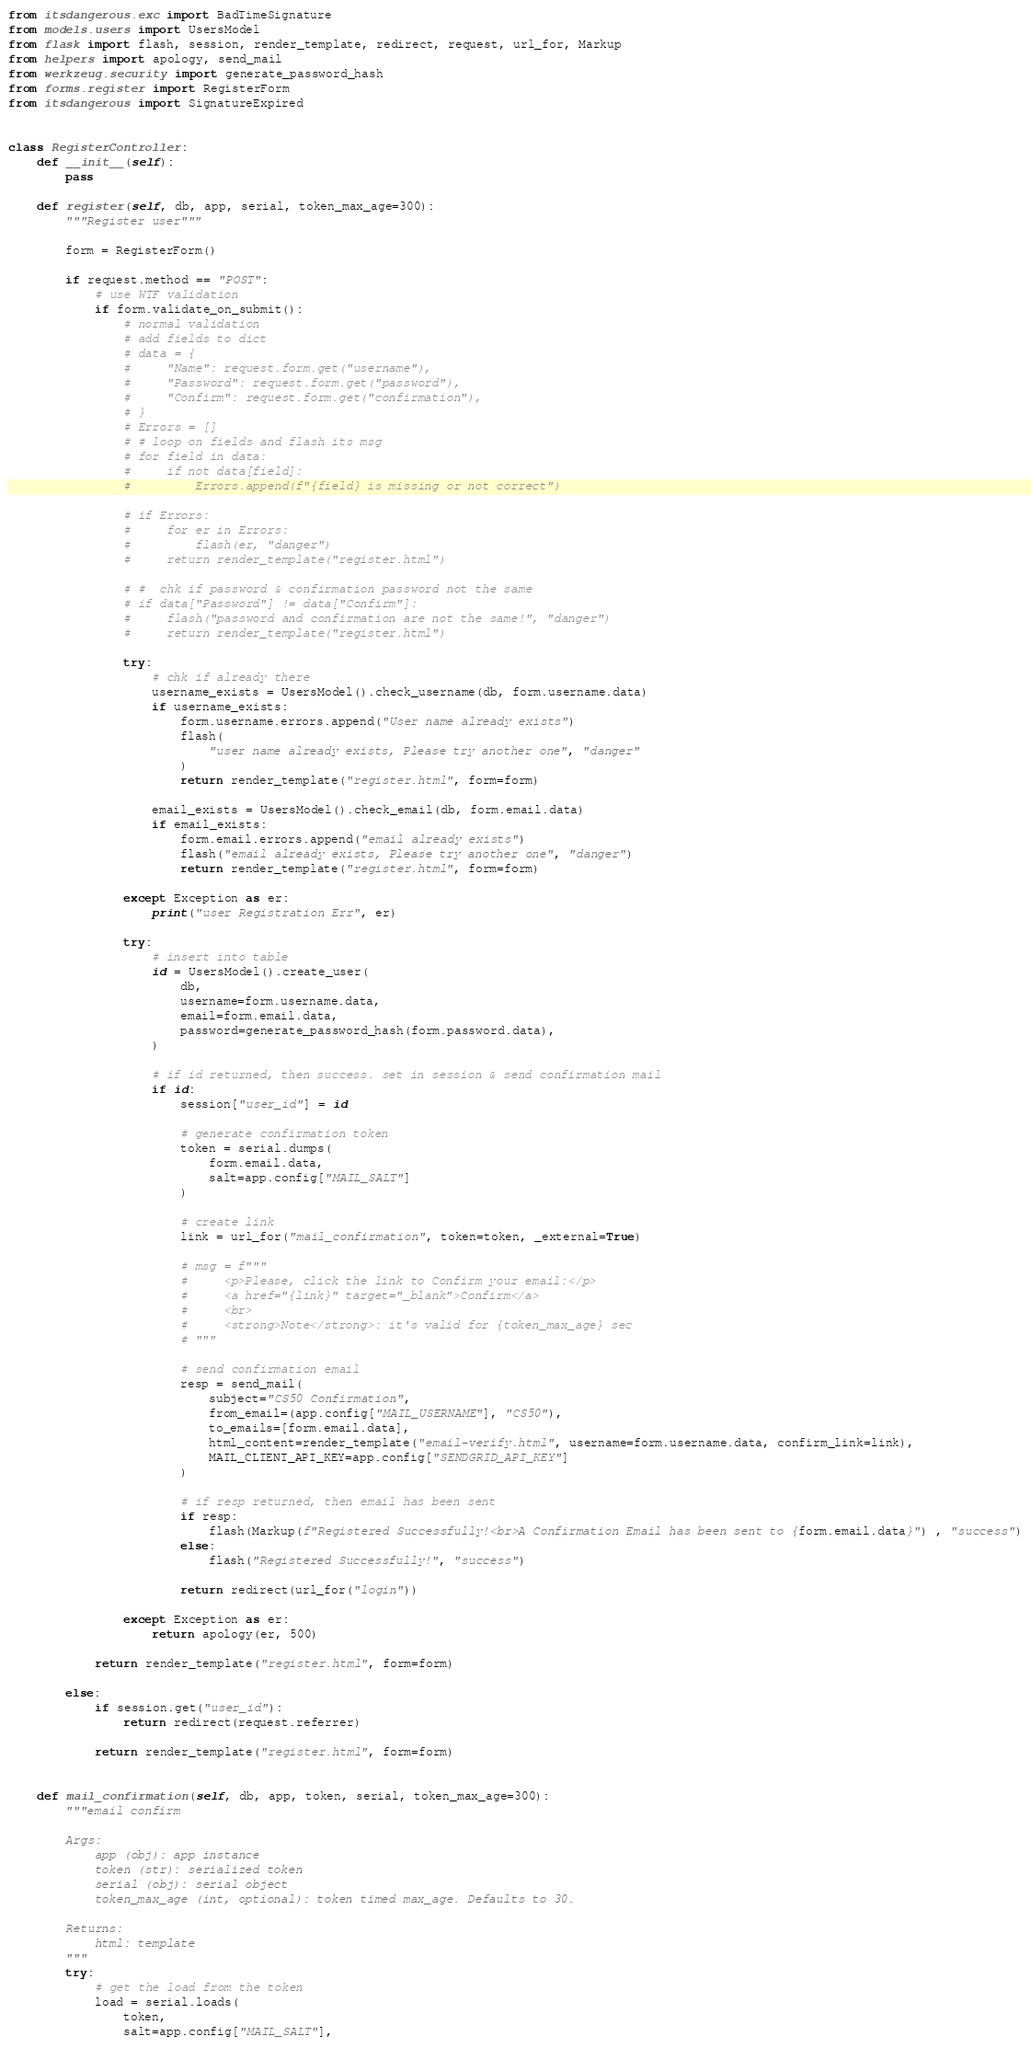<code> <loc_0><loc_0><loc_500><loc_500><_Python_>from itsdangerous.exc import BadTimeSignature
from models.users import UsersModel
from flask import flash, session, render_template, redirect, request, url_for, Markup
from helpers import apology, send_mail
from werkzeug.security import generate_password_hash
from forms.register import RegisterForm
from itsdangerous import SignatureExpired


class RegisterController:
    def __init__(self):
        pass

    def register(self, db, app, serial, token_max_age=300):
        """Register user"""

        form = RegisterForm()

        if request.method == "POST":
            # use WTF validation
            if form.validate_on_submit():
                # normal validation
                # add fields to dict
                # data = {
                #     "Name": request.form.get("username"),
                #     "Password": request.form.get("password"),
                #     "Confirm": request.form.get("confirmation"),
                # }
                # Errors = []
                # # loop on fields and flash its msg
                # for field in data:
                #     if not data[field]:
                #         Errors.append(f"{field} is missing or not correct")

                # if Errors:
                #     for er in Errors:
                #         flash(er, "danger")
                #     return render_template("register.html")

                # #  chk if password & confirmation password not the same
                # if data["Password"] != data["Confirm"]:
                #     flash("password and confirmation are not the same!", "danger")
                #     return render_template("register.html")

                try:
                    # chk if already there
                    username_exists = UsersModel().check_username(db, form.username.data)
                    if username_exists:
                        form.username.errors.append("User name already exists")
                        flash(
                            "user name already exists, Please try another one", "danger"
                        )
                        return render_template("register.html", form=form)

                    email_exists = UsersModel().check_email(db, form.email.data)
                    if email_exists:
                        form.email.errors.append("email already exists")
                        flash("email already exists, Please try another one", "danger")
                        return render_template("register.html", form=form)

                except Exception as er:
                    print("user Registration Err", er)

                try:
                    # insert into table
                    id = UsersModel().create_user(
                        db,
                        username=form.username.data,
                        email=form.email.data,
                        password=generate_password_hash(form.password.data),
                    )

                    # if id returned, then success. set in session & send confirmation mail
                    if id:
                        session["user_id"] = id

                        # generate confirmation token
                        token = serial.dumps(
                            form.email.data, 
                            salt=app.config["MAIL_SALT"]
                        )

                        # create link
                        link = url_for("mail_confirmation", token=token, _external=True)

                        # msg = f"""
                        #     <p>Please, click the link to Confirm your email:</p> 
                        #     <a href="{link}" target="_blank">Confirm</a> 
                        #     <br> 
                        #     <strong>Note</strong>: it's valid for {token_max_age} sec
                        # """

                        # send confirmation email
                        resp = send_mail(
                            subject="CS50 Confirmation",
                            from_email=(app.config["MAIL_USERNAME"], "CS50"),
                            to_emails=[form.email.data],
                            html_content=render_template("email-verify.html", username=form.username.data, confirm_link=link),
                            MAIL_CLIENT_API_KEY=app.config["SENDGRID_API_KEY"]
                        )

                        # if resp returned, then email has been sent
                        if resp:
                            flash(Markup(f"Registered Successfully!<br>A Confirmation Email has been sent to {form.email.data}") , "success")
                        else:
                            flash("Registered Successfully!", "success")

                        return redirect(url_for("login"))

                except Exception as er:
                    return apology(er, 500)

            return render_template("register.html", form=form)

        else:
            if session.get("user_id"):
                return redirect(request.referrer)

            return render_template("register.html", form=form)


    def mail_confirmation(self, db, app, token, serial, token_max_age=300):
        """email confirm

        Args:
            app (obj): app instance
            token (str): serialized token
            serial (obj): serial object
            token_max_age (int, optional): token timed max_age. Defaults to 30.

        Returns:
            html: template
        """
        try:
            # get the load from the token
            load = serial.loads(
                token, 
                salt=app.config["MAIL_SALT"], </code> 